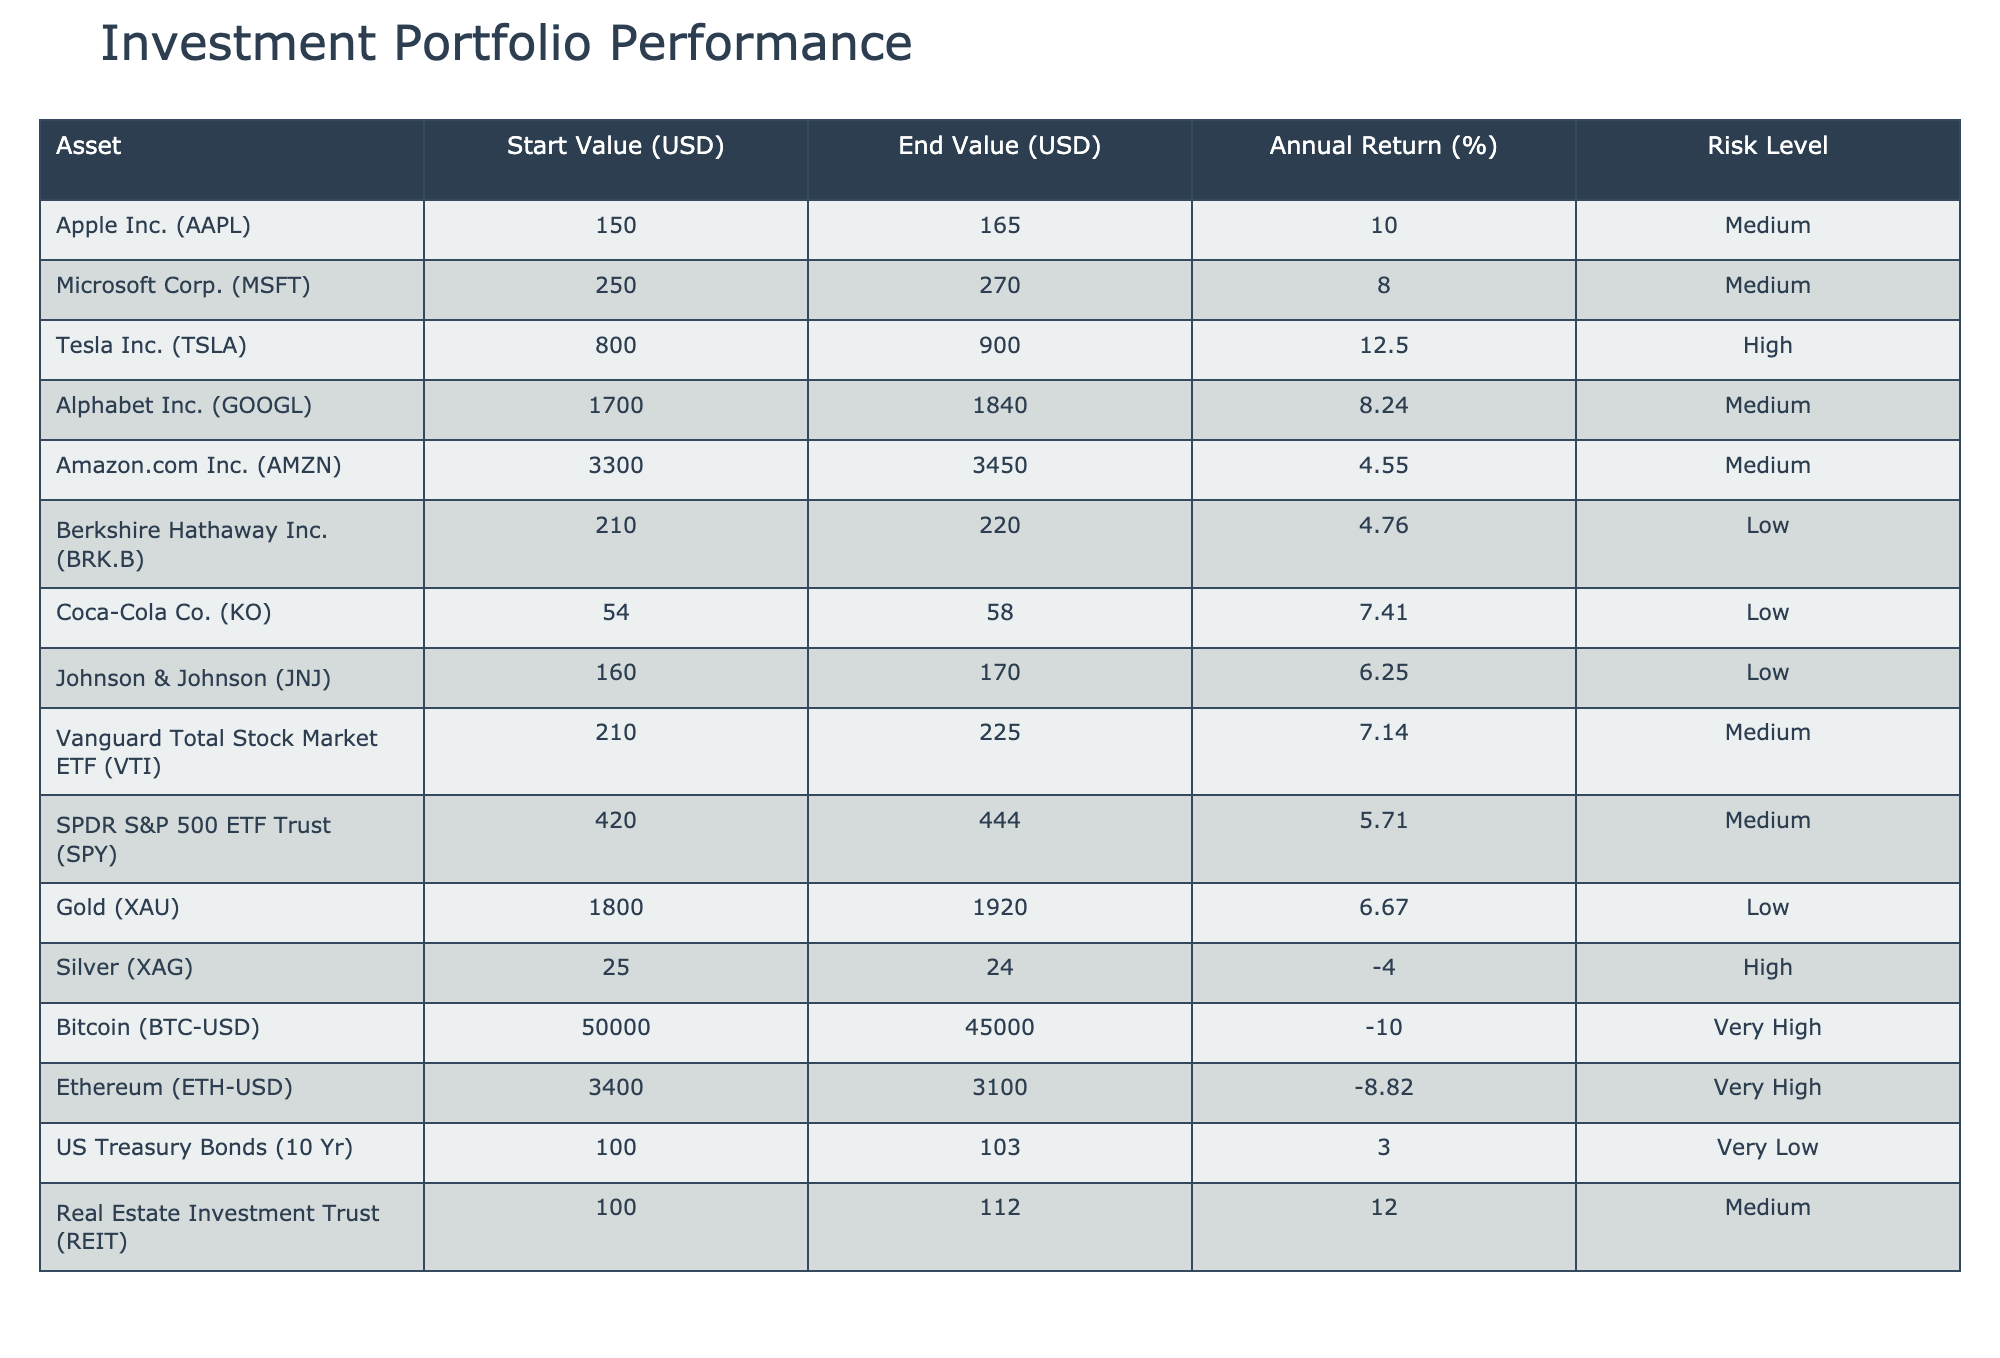What is the start value of Tesla Inc.? The table lists Tesla Inc. under the asset column, and in the corresponding row, the start value is provided in the "Start Value (USD)" column. The value is 800.00.
Answer: 800.00 Which asset had the highest annual return? To determine the highest annual return, we compare the values in the "Annual Return (%)" column. The highest value is 12.50, which corresponds to Tesla Inc.
Answer: Tesla Inc. (TSLA) What is the total end value of all assets listed in the table? We sum the "End Value (USD)" column values: 165 + 270 + 900 + 1840 + 3450 + 220 + 58 + 170 + 225 + 444 + 1920 + 24 + 45000 + 3100 + 103 + 112 = 58194.
Answer: 58194 Is the average annual return for the assets labeled as 'Medium' greater than 8%? First, we identify all assets marked 'Medium': Apple, Microsoft, Alphabet, Vanguard ETF, SPDR ETF, Real Estate Trust. Their annual returns are: 10.00, 8.00, 8.24, 7.14, 5.71, 12.00. The average is calculated as (10.00 + 8.00 + 8.24 + 7.14 + 5.71 + 12.00) / 6 = 8.52. This is greater than 8%.
Answer: Yes What is the difference between the start value and end value of Bitcoin? To find this difference, we take the start value of Bitcoin (50000) and subtract the end value (45000). Thus, 50000 - 45000 = 5000.
Answer: 5000 